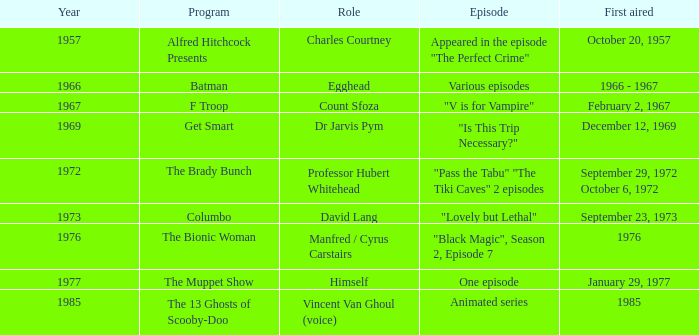What's the episode of Batman? Various episodes. 